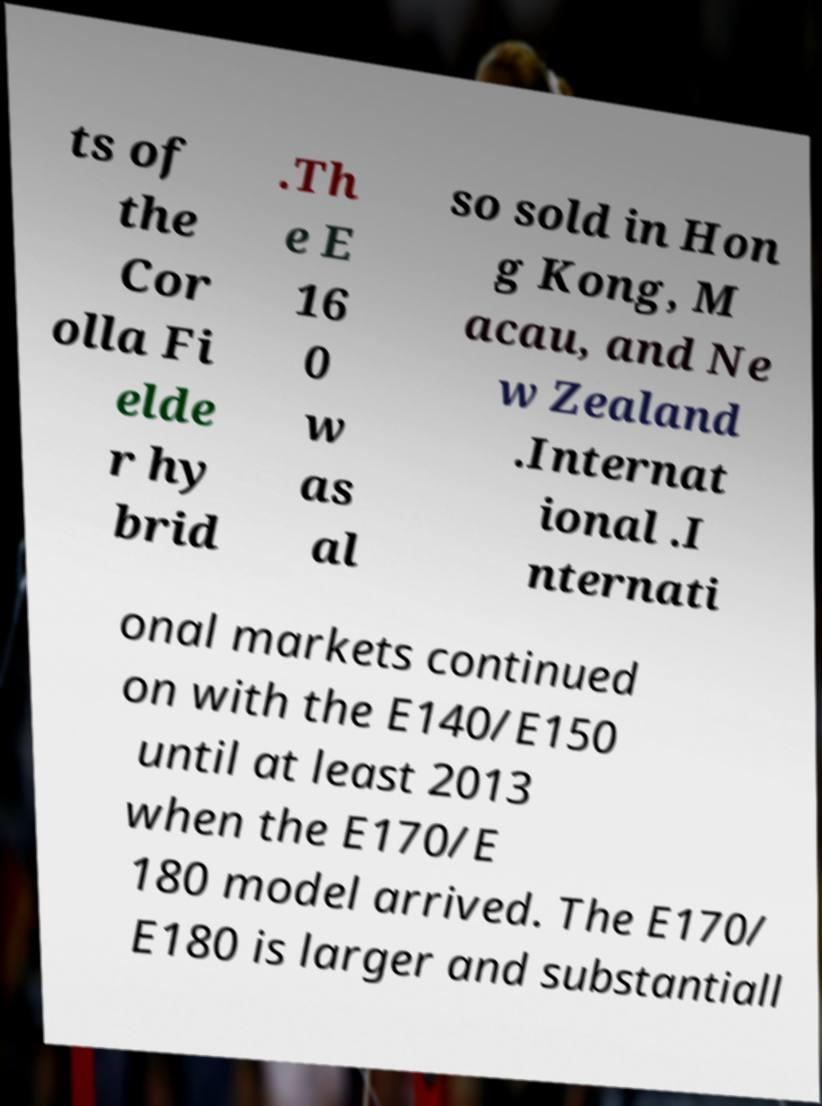Please read and relay the text visible in this image. What does it say? ts of the Cor olla Fi elde r hy brid .Th e E 16 0 w as al so sold in Hon g Kong, M acau, and Ne w Zealand .Internat ional .I nternati onal markets continued on with the E140/E150 until at least 2013 when the E170/E 180 model arrived. The E170/ E180 is larger and substantiall 